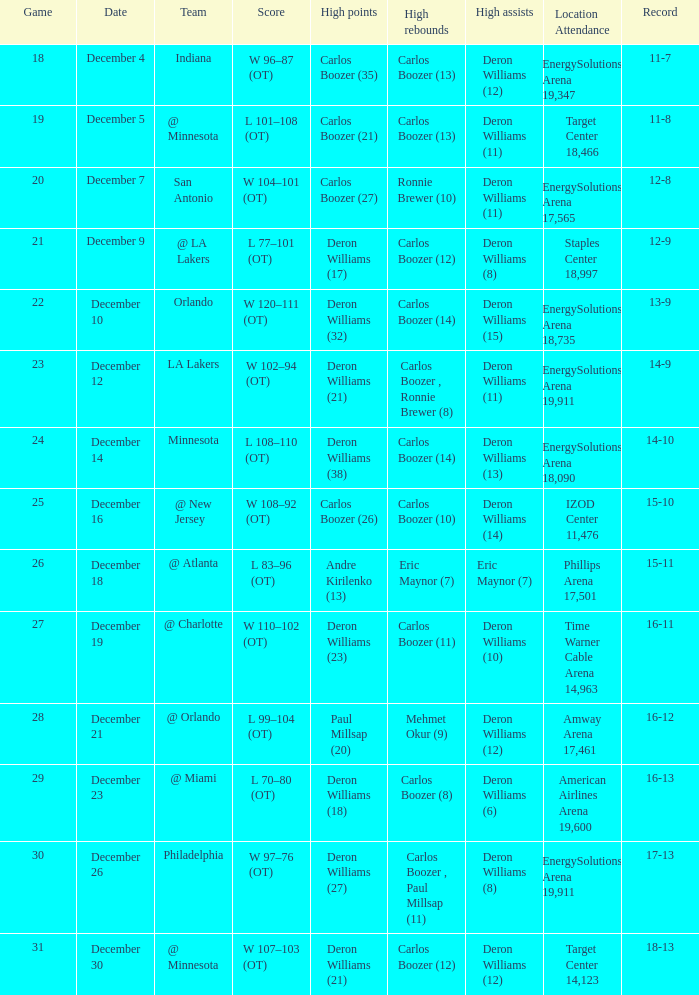When did the game where deron williams (13) achieved the most assists take place? December 14. Would you mind parsing the complete table? {'header': ['Game', 'Date', 'Team', 'Score', 'High points', 'High rebounds', 'High assists', 'Location Attendance', 'Record'], 'rows': [['18', 'December 4', 'Indiana', 'W 96–87 (OT)', 'Carlos Boozer (35)', 'Carlos Boozer (13)', 'Deron Williams (12)', 'EnergySolutions Arena 19,347', '11-7'], ['19', 'December 5', '@ Minnesota', 'L 101–108 (OT)', 'Carlos Boozer (21)', 'Carlos Boozer (13)', 'Deron Williams (11)', 'Target Center 18,466', '11-8'], ['20', 'December 7', 'San Antonio', 'W 104–101 (OT)', 'Carlos Boozer (27)', 'Ronnie Brewer (10)', 'Deron Williams (11)', 'EnergySolutions Arena 17,565', '12-8'], ['21', 'December 9', '@ LA Lakers', 'L 77–101 (OT)', 'Deron Williams (17)', 'Carlos Boozer (12)', 'Deron Williams (8)', 'Staples Center 18,997', '12-9'], ['22', 'December 10', 'Orlando', 'W 120–111 (OT)', 'Deron Williams (32)', 'Carlos Boozer (14)', 'Deron Williams (15)', 'EnergySolutions Arena 18,735', '13-9'], ['23', 'December 12', 'LA Lakers', 'W 102–94 (OT)', 'Deron Williams (21)', 'Carlos Boozer , Ronnie Brewer (8)', 'Deron Williams (11)', 'EnergySolutions Arena 19,911', '14-9'], ['24', 'December 14', 'Minnesota', 'L 108–110 (OT)', 'Deron Williams (38)', 'Carlos Boozer (14)', 'Deron Williams (13)', 'EnergySolutions Arena 18,090', '14-10'], ['25', 'December 16', '@ New Jersey', 'W 108–92 (OT)', 'Carlos Boozer (26)', 'Carlos Boozer (10)', 'Deron Williams (14)', 'IZOD Center 11,476', '15-10'], ['26', 'December 18', '@ Atlanta', 'L 83–96 (OT)', 'Andre Kirilenko (13)', 'Eric Maynor (7)', 'Eric Maynor (7)', 'Phillips Arena 17,501', '15-11'], ['27', 'December 19', '@ Charlotte', 'W 110–102 (OT)', 'Deron Williams (23)', 'Carlos Boozer (11)', 'Deron Williams (10)', 'Time Warner Cable Arena 14,963', '16-11'], ['28', 'December 21', '@ Orlando', 'L 99–104 (OT)', 'Paul Millsap (20)', 'Mehmet Okur (9)', 'Deron Williams (12)', 'Amway Arena 17,461', '16-12'], ['29', 'December 23', '@ Miami', 'L 70–80 (OT)', 'Deron Williams (18)', 'Carlos Boozer (8)', 'Deron Williams (6)', 'American Airlines Arena 19,600', '16-13'], ['30', 'December 26', 'Philadelphia', 'W 97–76 (OT)', 'Deron Williams (27)', 'Carlos Boozer , Paul Millsap (11)', 'Deron Williams (8)', 'EnergySolutions Arena 19,911', '17-13'], ['31', 'December 30', '@ Minnesota', 'W 107–103 (OT)', 'Deron Williams (21)', 'Carlos Boozer (12)', 'Deron Williams (12)', 'Target Center 14,123', '18-13']]} 